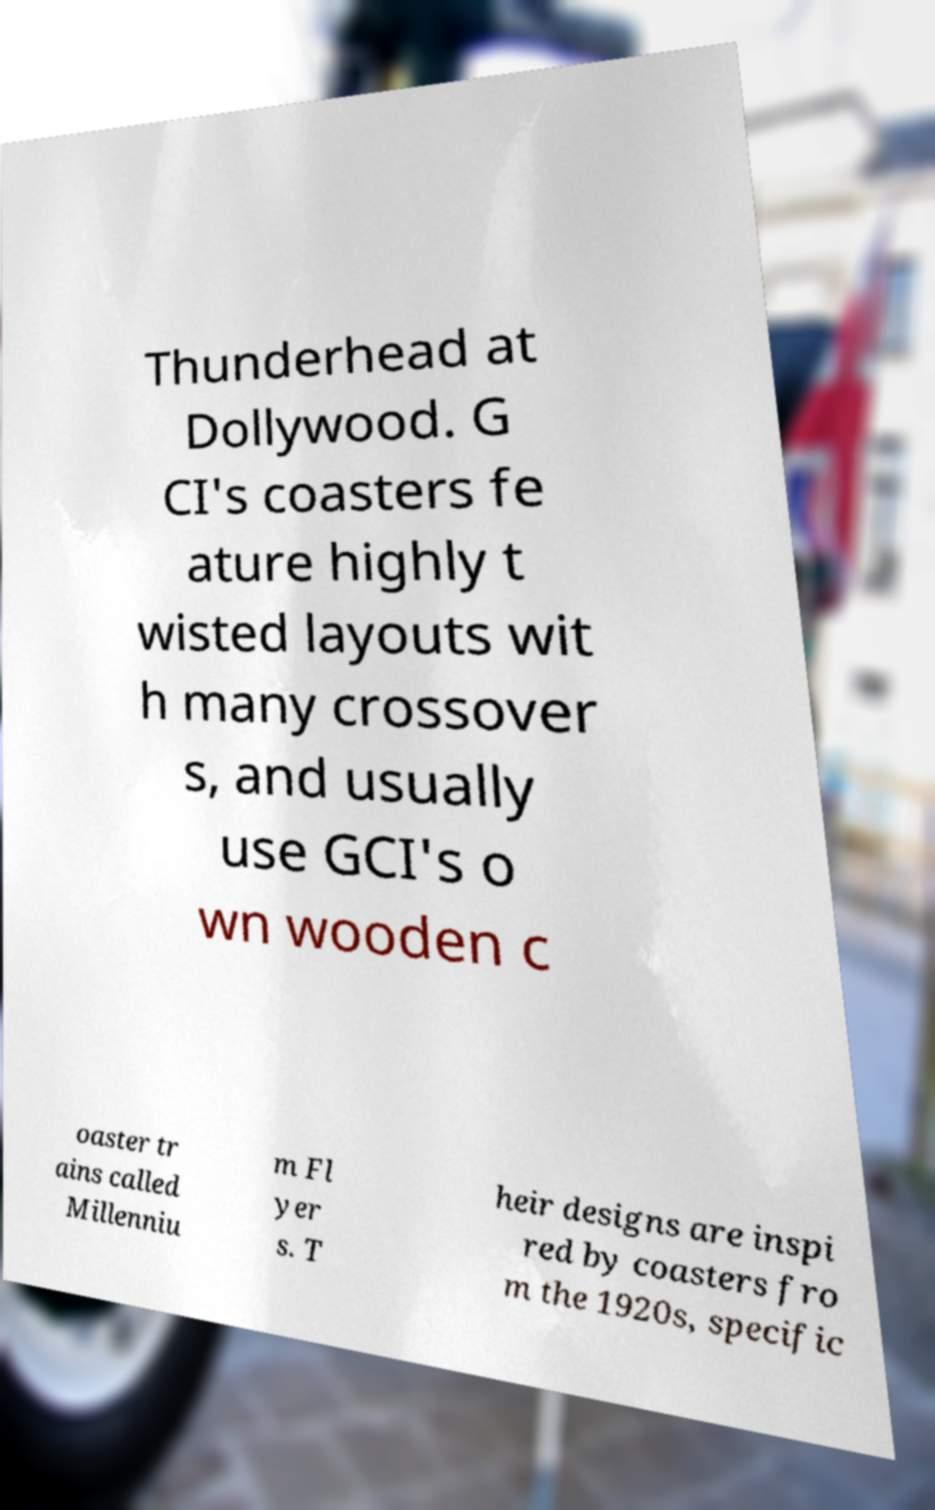I need the written content from this picture converted into text. Can you do that? Thunderhead at Dollywood. G CI's coasters fe ature highly t wisted layouts wit h many crossover s, and usually use GCI's o wn wooden c oaster tr ains called Millenniu m Fl yer s. T heir designs are inspi red by coasters fro m the 1920s, specific 